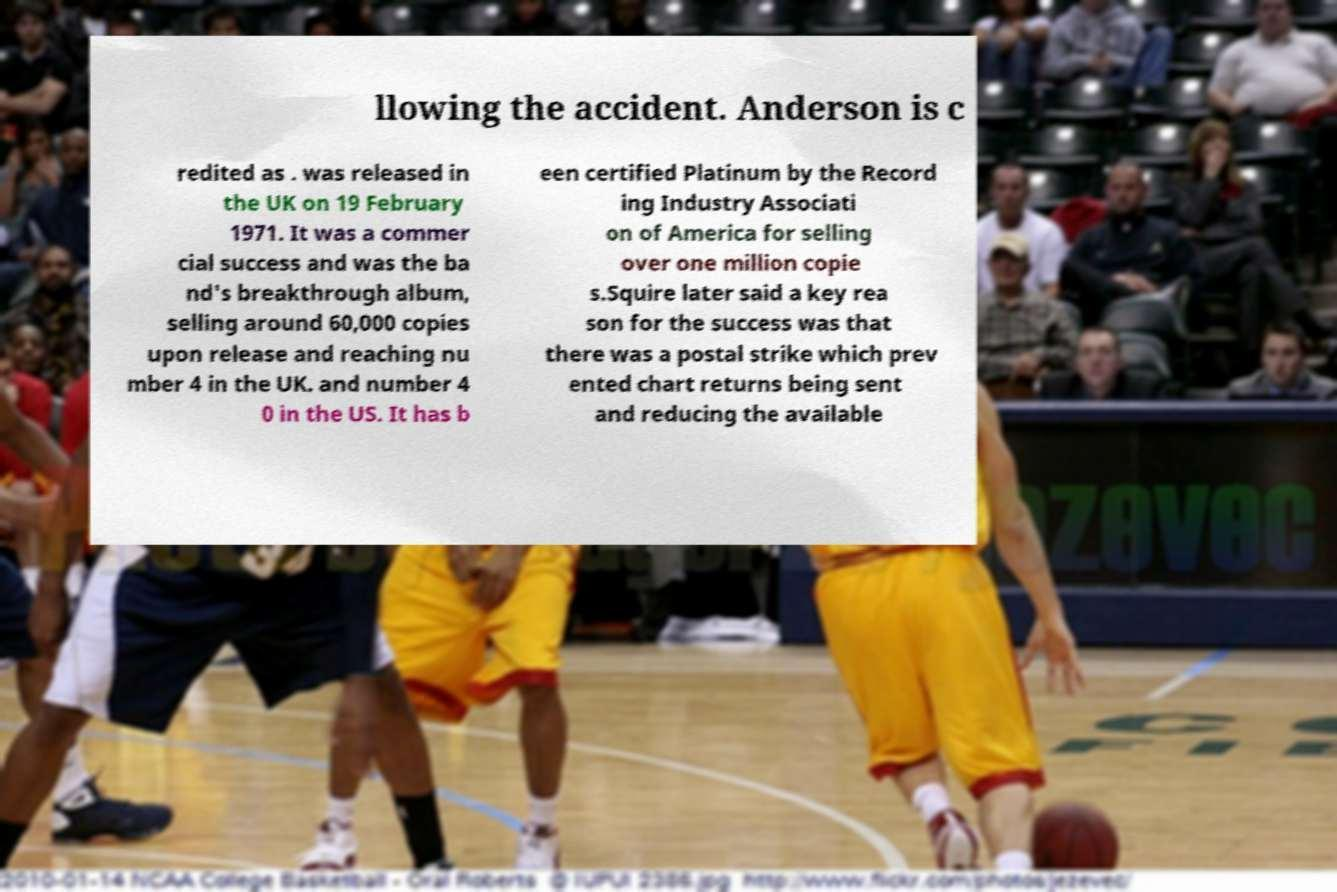Could you extract and type out the text from this image? llowing the accident. Anderson is c redited as . was released in the UK on 19 February 1971. It was a commer cial success and was the ba nd's breakthrough album, selling around 60,000 copies upon release and reaching nu mber 4 in the UK. and number 4 0 in the US. It has b een certified Platinum by the Record ing Industry Associati on of America for selling over one million copie s.Squire later said a key rea son for the success was that there was a postal strike which prev ented chart returns being sent and reducing the available 